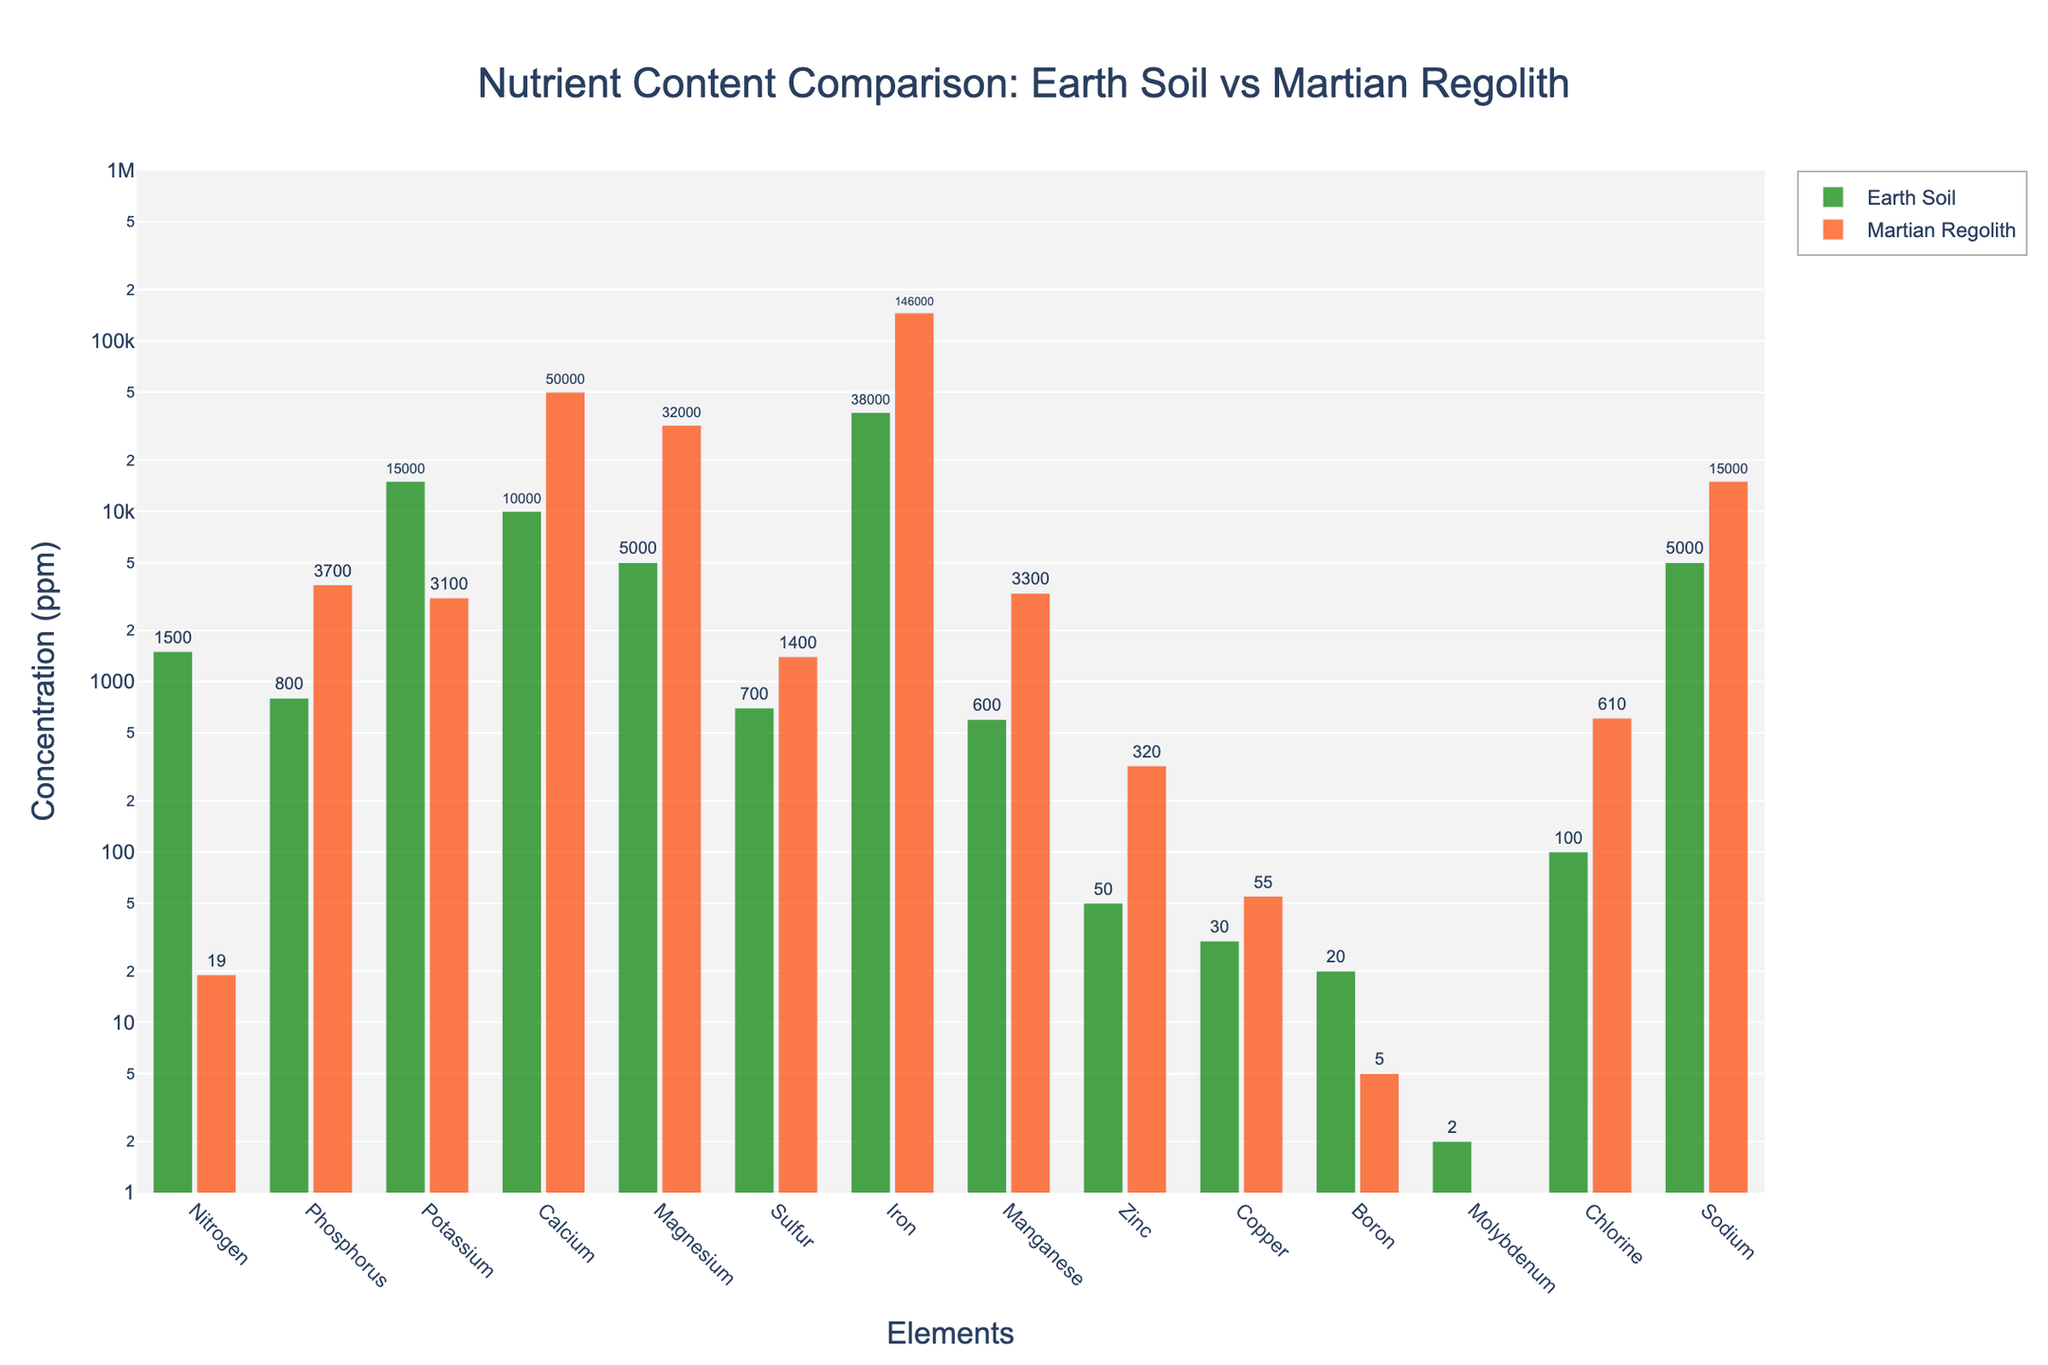What element has the highest concentration in Martian regolith? By inspecting the tallest bar in the plot for Martian regolith (the red bars), we can observe that Iron (Fe) has the highest concentration.
Answer: Iron What is the concentration difference in Nitrogen between Earth soil and Martian regolith? For Nitrogen, the plot shows Earth soil has a concentration of 1500 ppm, and Martian regolith has 19 ppm. The difference is calculated as 1500 - 19 = 1481 ppm.
Answer: 1481 ppm Which element has a higher concentration in Earth soil compared to Martian regolith by the smallest margin? By examining the plot, we can see that Boron has 20 ppm in Earth soil and 5 ppm in Martian regolith. The difference is 20 - 5 = 15 ppm, which is the smallest margin among the elements where Earth soil has a higher concentration.
Answer: Boron For which element is the concentration in Martian regolith approximately one order of magnitude higher than in Earth soil? Comparing the concentrations, we can see that Magnesium has 5000 ppm in Earth soil and 32000 ppm in Martian regolith, which is approximately one order of magnitude higher.
Answer: Magnesium What is the average concentration of Sodium and Chlorine in Martian regolith? The concentrations for Sodium and Chlorine in Martian regolith are 15000 ppm and 610 ppm respectively. Averaging these values: (15000 + 610) / 2 = 7805 ppm.
Answer: 7805 ppm Which three elements have higher concentrations in Martian regolith than in Earth soil? From the plot, it is visible that Phosphorus, Magnesium, and Iron have higher concentrations in Martian regolith than in Earth soil.
Answer: Phosphorus, Magnesium, Iron What is the sum of the concentrations of Calcium and Sulfur in Earth soil? According to the plot, Calcium in Earth soil is 10000 ppm and Sulfur is 700 ppm. Summing these values: 10000 + 700 = 10700 ppm.
Answer: 10700 ppm How does the concentration of Copper in Martian regolith compare to that in Earth soil? The plot shows that Copper has a concentration of 30 ppm in Earth soil and 55 ppm in Martian regolith. Copper is more concentrated in Martian regolith.
Answer: More concentrated in Martian regolith What is the median concentration of all elements in Earth soil? To find the median, we list all the concentrations in ascending order for Earth soil: 2, 20, 30, 50, 100, 600, 700, 1500, 5000, 5000, 10000, 15000, 38000. Since there are 13 values, the median is the 7th value. The 7th value is 700 ppm.
Answer: 700 ppm Which element shows the largest relative increase in concentration from Earth soil to Martian regolith? By calculating the relative increase ((Martian - Earth)/Earth), we find that Chlorine has Earth soil 100 ppm and Martian regolith 610 ppm. Relative increase: (610 - 100)/100 = 5.1 or 510%. This is the largest relative increase.
Answer: Chlorine 